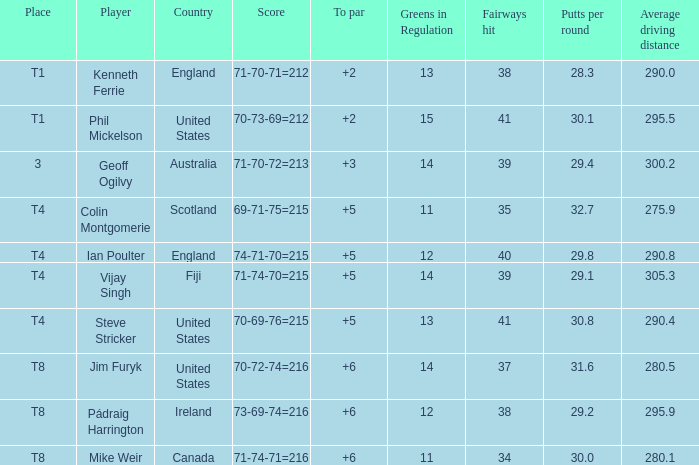Who had a score of 70-73-69=212? Phil Mickelson. 